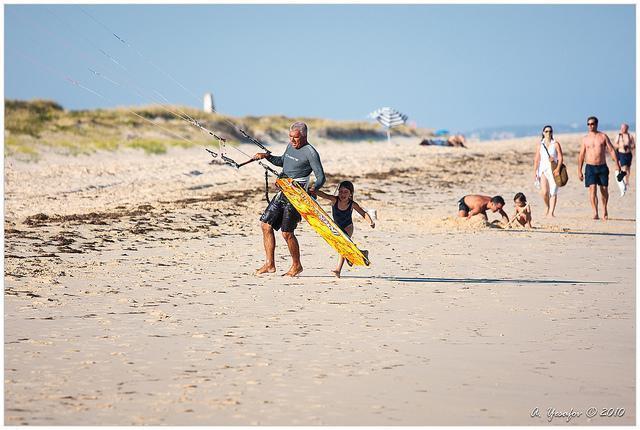What is the man helping the young woman with in the sand?
Choose the correct response, then elucidate: 'Answer: answer
Rationale: rationale.'
Options: Collect turtles, collect water, lay towel, build sandcastle. Answer: build sandcastle.
Rationale: He is playing in the sand building things with her. 